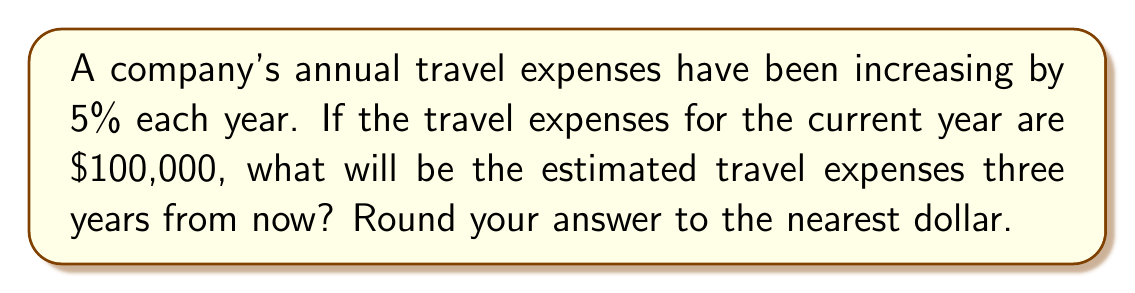Give your solution to this math problem. Let's approach this step-by-step:

1) We start with the current year's expenses: $100,000

2) Each year, the expenses increase by 5%. This means we need to multiply by 1.05 for each year:
   - After 1 year: $100,000 * 1.05
   - After 2 years: $100,000 * 1.05 * 1.05
   - After 3 years: $100,000 * 1.05 * 1.05 * 1.05

3) We can simplify this as:
   $100,000 * (1.05)^3$

4) Let's calculate:
   $100,000 * (1.05)^3 = 100,000 * 1.157625 = 115,762.50$

5) Rounding to the nearest dollar:
   $115,763

Therefore, the estimated travel expenses three years from now will be $115,763.
Answer: $115,763 